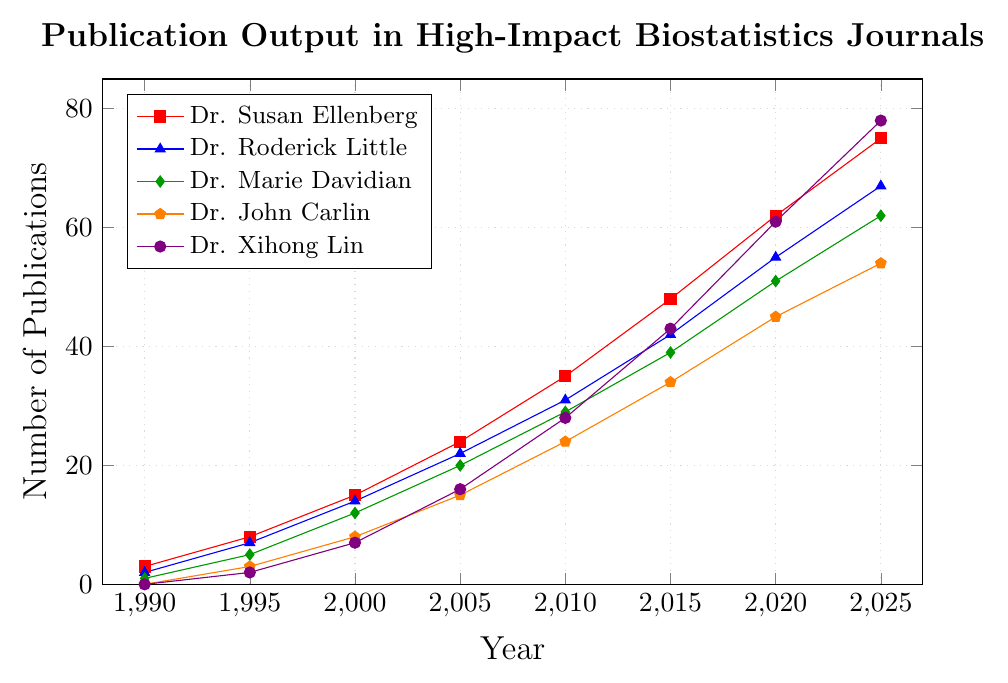What is the number of publications by Dr. Xihong Lin in 2025? The line chart shows the publication output of Dr. Xihong Lin in the year 2025, which can be read directly from the plot.
Answer: 78 Who has the most publications in 2010, and how many? By examining the plot, the line representing Dr. Xihong Lin in 2010 is the highest compared to others.
Answer: Dr. Xihong Lin, 28 How many more publications does Dr. Susan Ellenberg have in 2020 than in 1990? Find Dr. Susan Ellenberg's publications in 2020 (62) and 1990 (3), then calculate the difference: 62 - 3.
Answer: 59 Which researchers had zero publications in 1990? By looking at the lines for the year 1990, both Dr. John Carlin and Dr. Xihong Lin had zero publications.
Answer: Dr. John Carlin, Dr. Xihong Lin What is the combined publication output in 2000 for Dr. Roderick Little and Dr. Marie Davidian? Sum the number of publications for Dr. Roderick Little (14) and Dr. Marie Davidian (12) in 2000.
Answer: 26 Who had the fewest publications in 2015 and what was the number? The lowest point among all researchers in 2015 is Dr. Marie Davidian with 39 publications.
Answer: Dr. Marie Davidian, 39 Compare the publication output of Dr. John Carlin and Dr. Xihong Lin in 2005. Who had more, and by how much? In 2005, Dr. John Carlin had 15 publications and Dr. Xihong Lin had 16. The difference is 16 - 15.
Answer: Dr. Xihong Lin, by 1 What is the average number of publications for Dr. Susan Ellenberg across all years represented in the chart? Sum the number of publications in all years for Dr. Susan Ellenberg and divide by the number of years (8): (3 + 8 + 15 + 24 + 35 + 48 + 62 + 75) / 8.
Answer: 34 Identify the overall trend in publication output for Dr. Roderick Little over the years. The number of publications for Dr. Roderick Little consistently increases from 2 in 1990 to 67 in 2025, indicating a steady upward trend.
Answer: Steady upward trend 